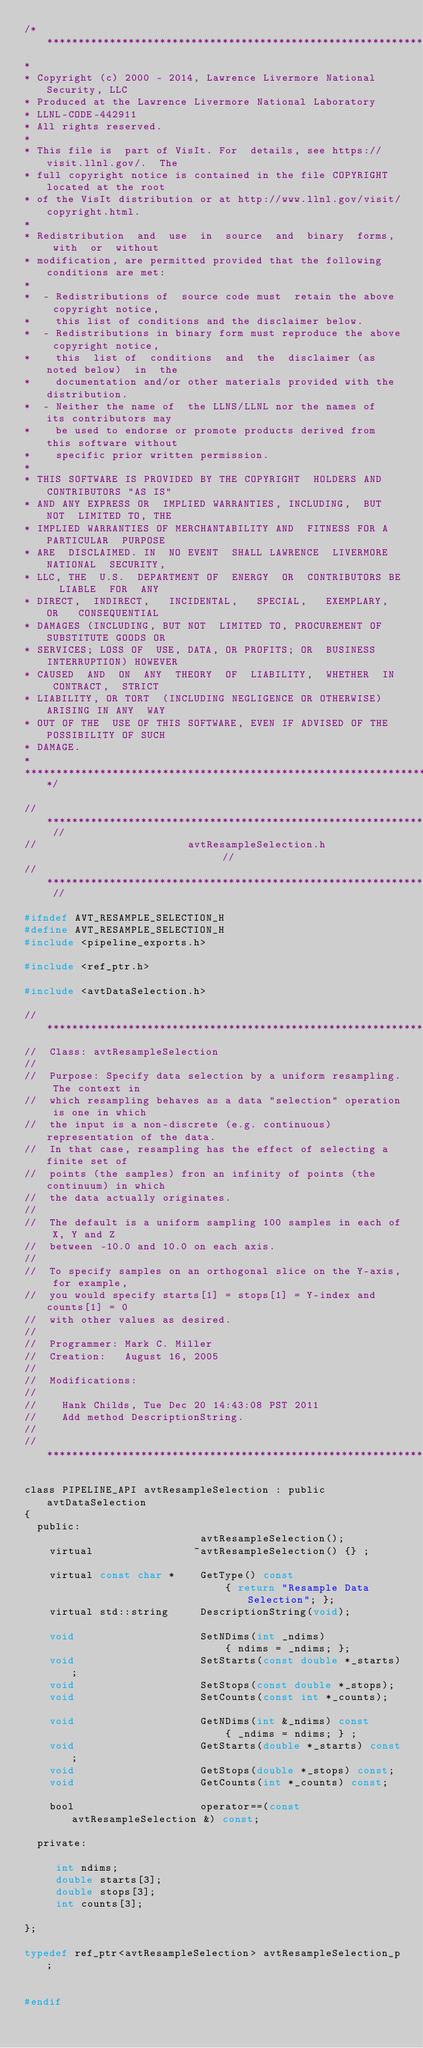Convert code to text. <code><loc_0><loc_0><loc_500><loc_500><_C_>/*****************************************************************************
*
* Copyright (c) 2000 - 2014, Lawrence Livermore National Security, LLC
* Produced at the Lawrence Livermore National Laboratory
* LLNL-CODE-442911
* All rights reserved.
*
* This file is  part of VisIt. For  details, see https://visit.llnl.gov/.  The
* full copyright notice is contained in the file COPYRIGHT located at the root
* of the VisIt distribution or at http://www.llnl.gov/visit/copyright.html.
*
* Redistribution  and  use  in  source  and  binary  forms,  with  or  without
* modification, are permitted provided that the following conditions are met:
*
*  - Redistributions of  source code must  retain the above  copyright notice,
*    this list of conditions and the disclaimer below.
*  - Redistributions in binary form must reproduce the above copyright notice,
*    this  list of  conditions  and  the  disclaimer (as noted below)  in  the
*    documentation and/or other materials provided with the distribution.
*  - Neither the name of  the LLNS/LLNL nor the names of  its contributors may
*    be used to endorse or promote products derived from this software without
*    specific prior written permission.
*
* THIS SOFTWARE IS PROVIDED BY THE COPYRIGHT  HOLDERS AND CONTRIBUTORS "AS IS"
* AND ANY EXPRESS OR  IMPLIED WARRANTIES, INCLUDING,  BUT NOT  LIMITED TO, THE
* IMPLIED WARRANTIES OF MERCHANTABILITY AND  FITNESS FOR A PARTICULAR  PURPOSE
* ARE  DISCLAIMED. IN  NO EVENT  SHALL LAWRENCE  LIVERMORE NATIONAL  SECURITY,
* LLC, THE  U.S.  DEPARTMENT OF  ENERGY  OR  CONTRIBUTORS BE  LIABLE  FOR  ANY
* DIRECT,  INDIRECT,   INCIDENTAL,   SPECIAL,   EXEMPLARY,  OR   CONSEQUENTIAL
* DAMAGES (INCLUDING, BUT NOT  LIMITED TO, PROCUREMENT OF  SUBSTITUTE GOODS OR
* SERVICES; LOSS OF  USE, DATA, OR PROFITS; OR  BUSINESS INTERRUPTION) HOWEVER
* CAUSED  AND  ON  ANY  THEORY  OF  LIABILITY,  WHETHER  IN  CONTRACT,  STRICT
* LIABILITY, OR TORT  (INCLUDING NEGLIGENCE OR OTHERWISE)  ARISING IN ANY  WAY
* OUT OF THE  USE OF THIS SOFTWARE, EVEN IF ADVISED OF THE POSSIBILITY OF SUCH
* DAMAGE.
*
*****************************************************************************/

// ************************************************************************* //
//                        avtResampleSelection.h                             //
// ************************************************************************* //

#ifndef AVT_RESAMPLE_SELECTION_H
#define AVT_RESAMPLE_SELECTION_H 
#include <pipeline_exports.h>

#include <ref_ptr.h>

#include <avtDataSelection.h>

// ****************************************************************************
//  Class: avtResampleSelection
//
//  Purpose: Specify data selection by a uniform resampling. The context in
//  which resampling behaves as a data "selection" operation is one in which
//  the input is a non-discrete (e.g. continuous) representation of the data.
//  In that case, resampling has the effect of selecting a finite set of 
//  points (the samples) fron an infinity of points (the continuum) in which
//  the data actually originates.
//
//  The default is a uniform sampling 100 samples in each of X, Y and Z
//  between -10.0 and 10.0 on each axis.
//
//  To specify samples on an orthogonal slice on the Y-axis, for example,
//  you would specify starts[1] = stops[1] = Y-index and counts[1] = 0
//  with other values as desired.
//
//  Programmer: Mark C. Miller 
//  Creation:   August 16, 2005 
//
//  Modifications:
//
//    Hank Childs, Tue Dec 20 14:43:08 PST 2011
//    Add method DescriptionString.
//
// ****************************************************************************

class PIPELINE_API avtResampleSelection : public avtDataSelection 
{
  public:
                            avtResampleSelection();
    virtual                ~avtResampleSelection() {} ;

    virtual const char *    GetType() const
                                { return "Resample Data Selection"; }; 
    virtual std::string     DescriptionString(void);

    void                    SetNDims(int _ndims)
                                { ndims = _ndims; };
    void                    SetStarts(const double *_starts);
    void                    SetStops(const double *_stops);
    void                    SetCounts(const int *_counts);

    void                    GetNDims(int &_ndims) const
                                { _ndims = ndims; } ; 
    void                    GetStarts(double *_starts) const;
    void                    GetStops(double *_stops) const;
    void                    GetCounts(int *_counts) const;

    bool                    operator==(const avtResampleSelection &) const;

  private:

     int ndims;
     double starts[3];
     double stops[3];
     int counts[3];

};

typedef ref_ptr<avtResampleSelection> avtResampleSelection_p;


#endif
</code> 